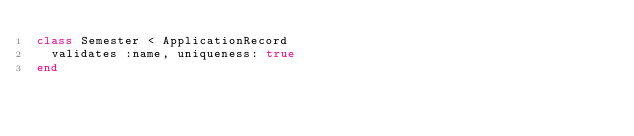Convert code to text. <code><loc_0><loc_0><loc_500><loc_500><_Ruby_>class Semester < ApplicationRecord
  validates :name, uniqueness: true
end
</code> 